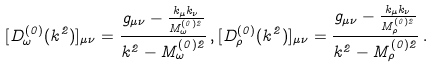<formula> <loc_0><loc_0><loc_500><loc_500>[ D _ { \omega } ^ { ( 0 ) } ( k ^ { 2 } ) ] _ { \mu \nu } = \frac { g _ { \mu \nu } - \frac { k _ { \mu } k _ { \nu } } { M ^ { ( 0 ) 2 } _ { \omega } } } { k ^ { 2 } - M ^ { ( 0 ) 2 } _ { \omega } } \, , [ D _ { \rho } ^ { ( 0 ) } ( k ^ { 2 } ) ] _ { \mu \nu } = \frac { g _ { \mu \nu } - \frac { k _ { \mu } k _ { \nu } } { M ^ { ( 0 ) 2 } _ { \rho } } } { k ^ { 2 } - M ^ { ( 0 ) 2 } _ { \rho } } \, .</formula> 